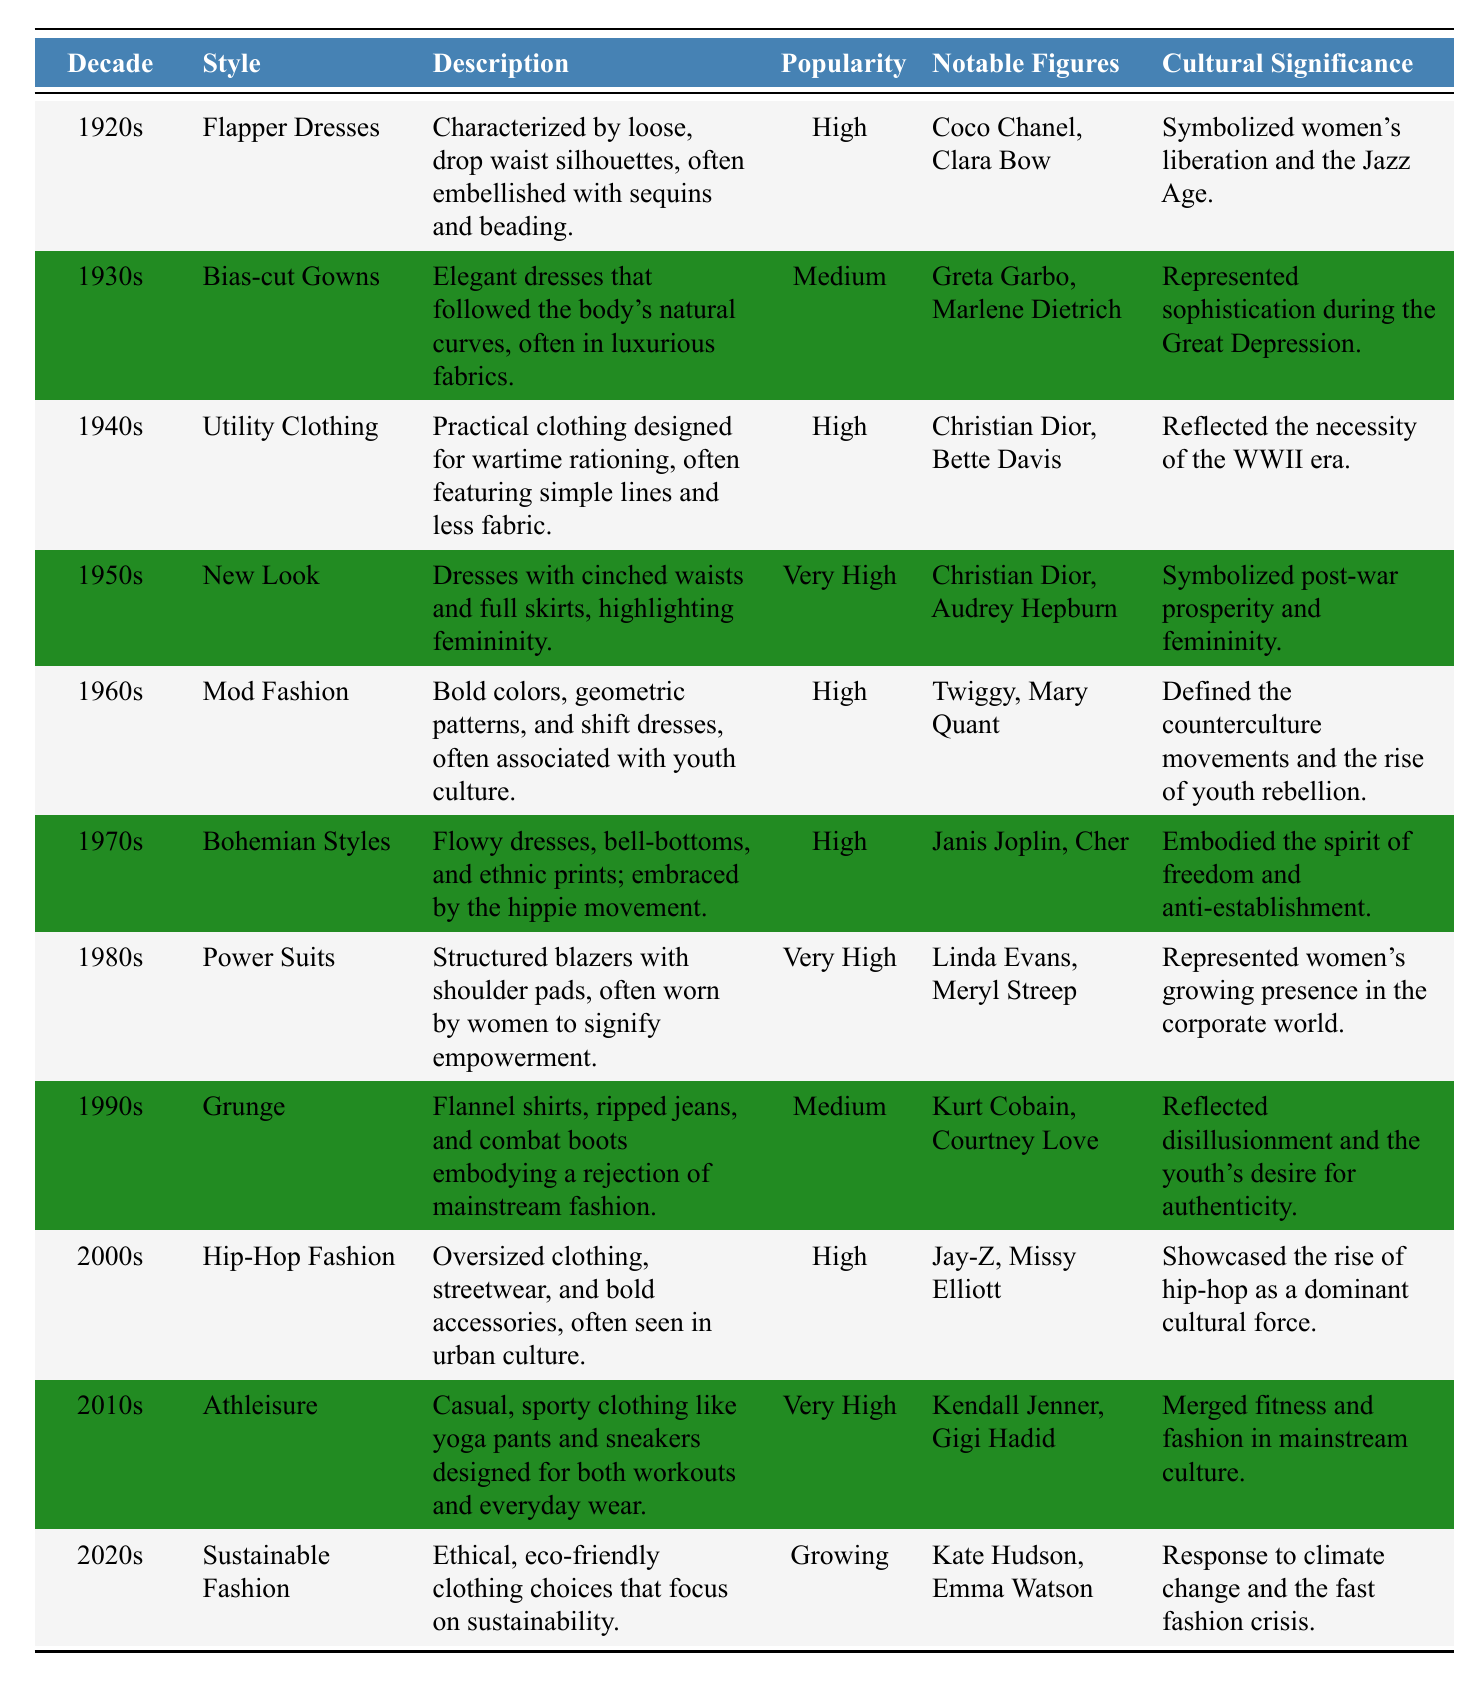What type of clothing was popular in the 1940s? According to the table, the style of clothing popular in the 1940s was "Utility Clothing."
Answer: Utility Clothing Which decade had the highest popularity rating for fashion styles? The decade that had the highest popularity rating is the 1950s with the "New Look," which is rated as "Very High."
Answer: 1950s How many notable figures are associated with the 1960s fashion? The 1960s fashion style "Mod Fashion" has two notable figures listed: Twiggy and Mary Quant.
Answer: 2 Was "Sustainable Fashion" considered popular in the 2020s? The table indicates that "Sustainable Fashion" is labeled as "Growing" in popularity, which suggests that it is becoming more accepted but not fully popular yet.
Answer: No In which decade did "Power Suits" become very popular, and who were two notable figures associated with it? "Power Suits" became very popular in the 1980s, and the notable figures associated with it are Linda Evans and Meryl Streep.
Answer: 1980s, Linda Evans and Meryl Streep Which fashion style from the 1970s is linked to the hippie movement? The fashion style from the 1970s that is linked to the hippie movement is "Bohemian Styles."
Answer: Bohemian Styles Of the styles listed, which decade's fashion is characterized by ethical and eco-friendly choices? The table states that "Sustainable Fashion," characterized by ethical and eco-friendly choices, corresponds to the 2020s.
Answer: 2020s Which two decades had a "Very High" popularity rating for their fashion styles? The decades that had a "Very High" popularity rating are the 1950s ("New Look") and the 1980s ("Power Suits").
Answer: 1950s and 1980s What is the cultural significance of the 1920s fashion? The cultural significance of the 1920s fashion, specifically flapper dresses, is that it symbolized women's liberation and the Jazz Age.
Answer: Women's liberation and the Jazz Age How do the popularity ratings of 1990s fashion compare to that of 1940s fashion? The 1990s fashion ("Grunge") has a popularity rating of "Medium," while the 1940s fashion ("Utility Clothing") has a popularity rating of "High," indicating that 1940s fashion was more popular.
Answer: 1940s fashion was more popular 